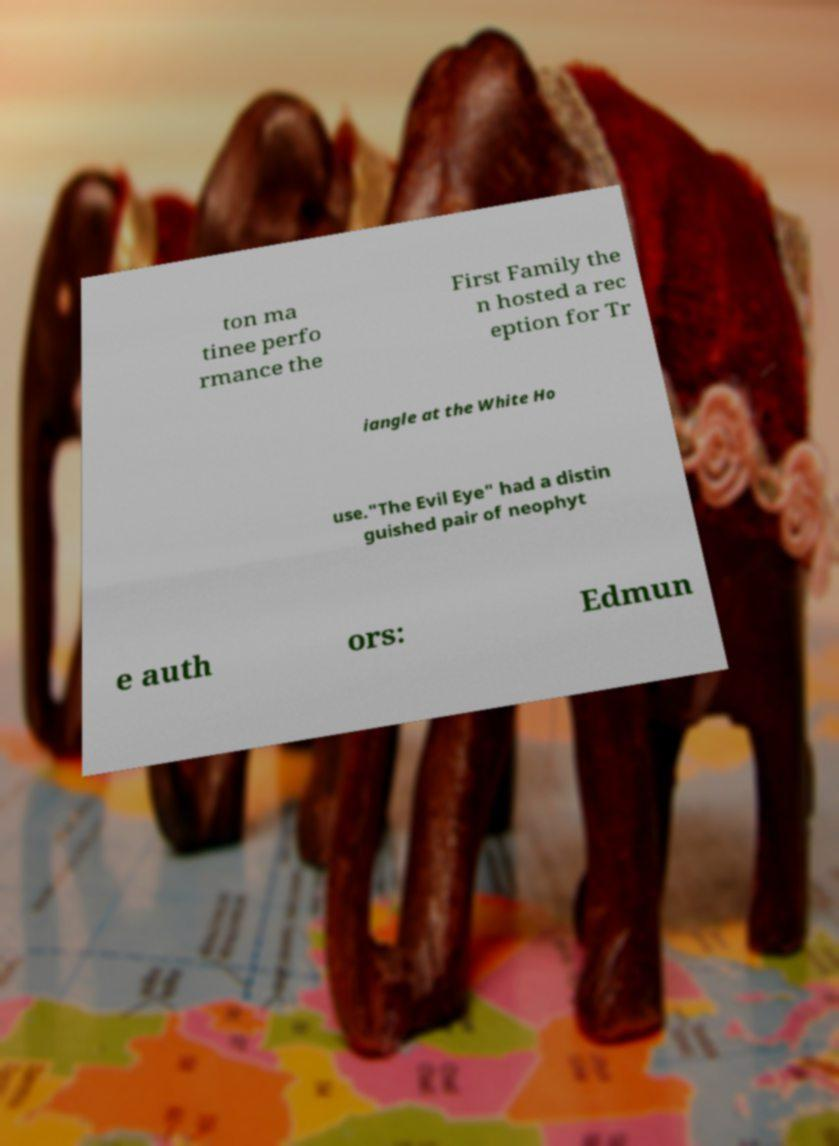Please read and relay the text visible in this image. What does it say? ton ma tinee perfo rmance the First Family the n hosted a rec eption for Tr iangle at the White Ho use."The Evil Eye" had a distin guished pair of neophyt e auth ors: Edmun 